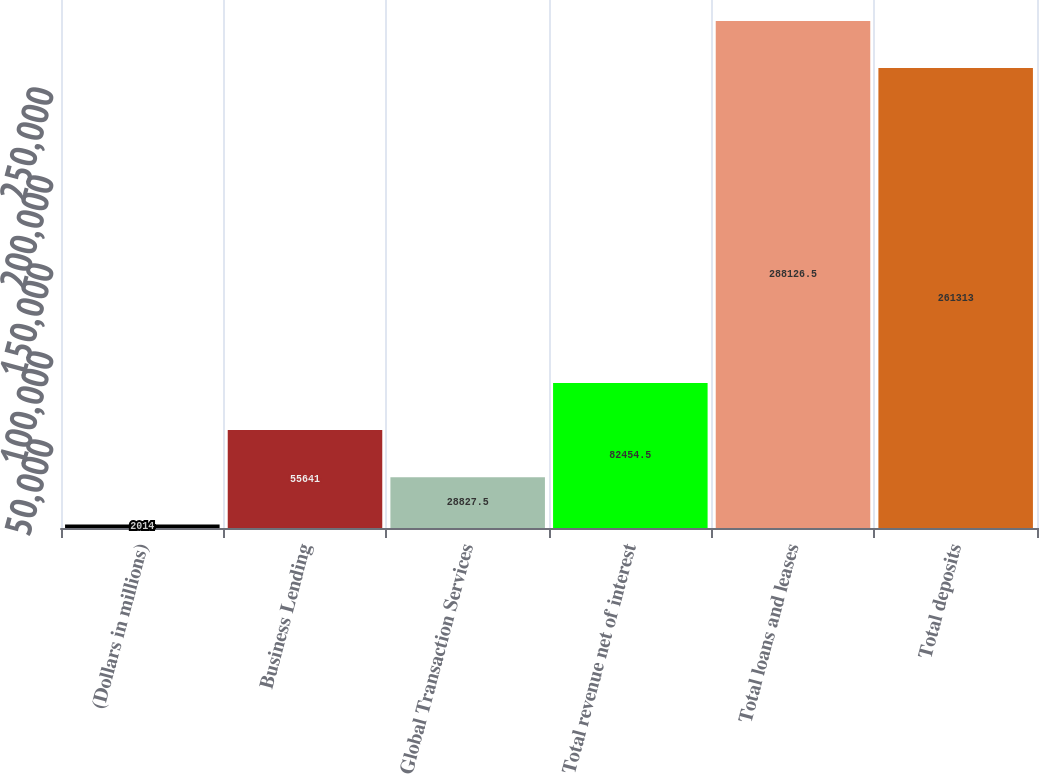Convert chart. <chart><loc_0><loc_0><loc_500><loc_500><bar_chart><fcel>(Dollars in millions)<fcel>Business Lending<fcel>Global Transaction Services<fcel>Total revenue net of interest<fcel>Total loans and leases<fcel>Total deposits<nl><fcel>2014<fcel>55641<fcel>28827.5<fcel>82454.5<fcel>288126<fcel>261313<nl></chart> 